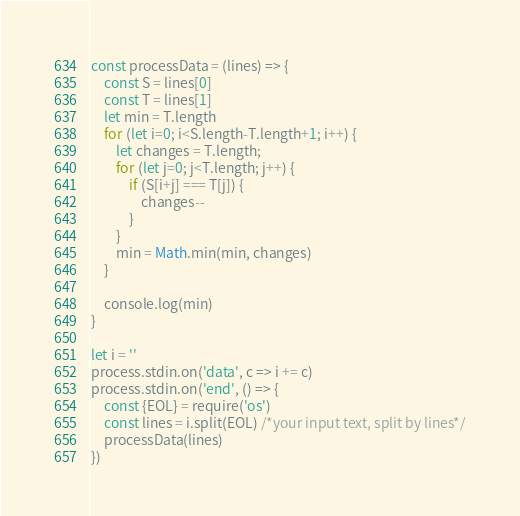<code> <loc_0><loc_0><loc_500><loc_500><_JavaScript_>const processData = (lines) => {
    const S = lines[0]
    const T = lines[1]
    let min = T.length
    for (let i=0; i<S.length-T.length+1; i++) {
        let changes = T.length;
        for (let j=0; j<T.length; j++) {
            if (S[i+j] === T[j]) {
                changes--
            }
        }
        min = Math.min(min, changes)
    }

    console.log(min)
}

let i = ''
process.stdin.on('data', c => i += c)
process.stdin.on('end', () => {
    const {EOL} = require('os')
    const lines = i.split(EOL) /*your input text, split by lines*/
    processData(lines)
})
</code> 